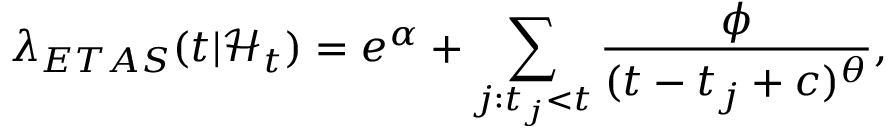<formula> <loc_0><loc_0><loc_500><loc_500>\lambda _ { E T A S } ( t | \mathcal { H } _ { t } ) = e ^ { \alpha } + \sum _ { j \colon t _ { j } < t } \frac { \phi } { ( t - t _ { j } + c ) ^ { \theta } } ,</formula> 